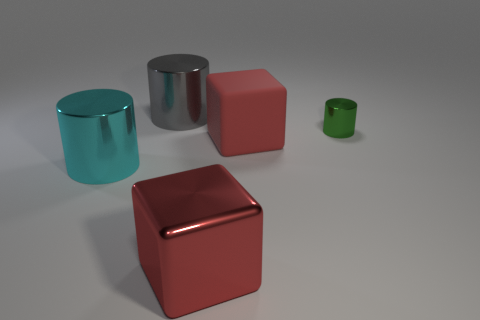Is there any other thing that has the same size as the green cylinder?
Your response must be concise. No. There is a thing that is the same color as the big shiny cube; what is its shape?
Offer a very short reply. Cube. The thing that is both in front of the matte object and behind the large red metal block is made of what material?
Offer a terse response. Metal. Do the cyan cylinder that is left of the rubber cube and the big red metallic cube have the same size?
Offer a very short reply. Yes. Does the small shiny cylinder have the same color as the large rubber object?
Give a very brief answer. No. What number of metal things are to the left of the tiny green object and in front of the large gray metallic cylinder?
Offer a very short reply. 2. What number of cylinders are behind the cylinder to the right of the object that is behind the tiny green metal thing?
Make the answer very short. 1. What size is the metallic object that is the same color as the large matte thing?
Provide a succinct answer. Large. The big rubber thing is what shape?
Ensure brevity in your answer.  Cube. What number of tiny cyan spheres have the same material as the small green cylinder?
Ensure brevity in your answer.  0. 